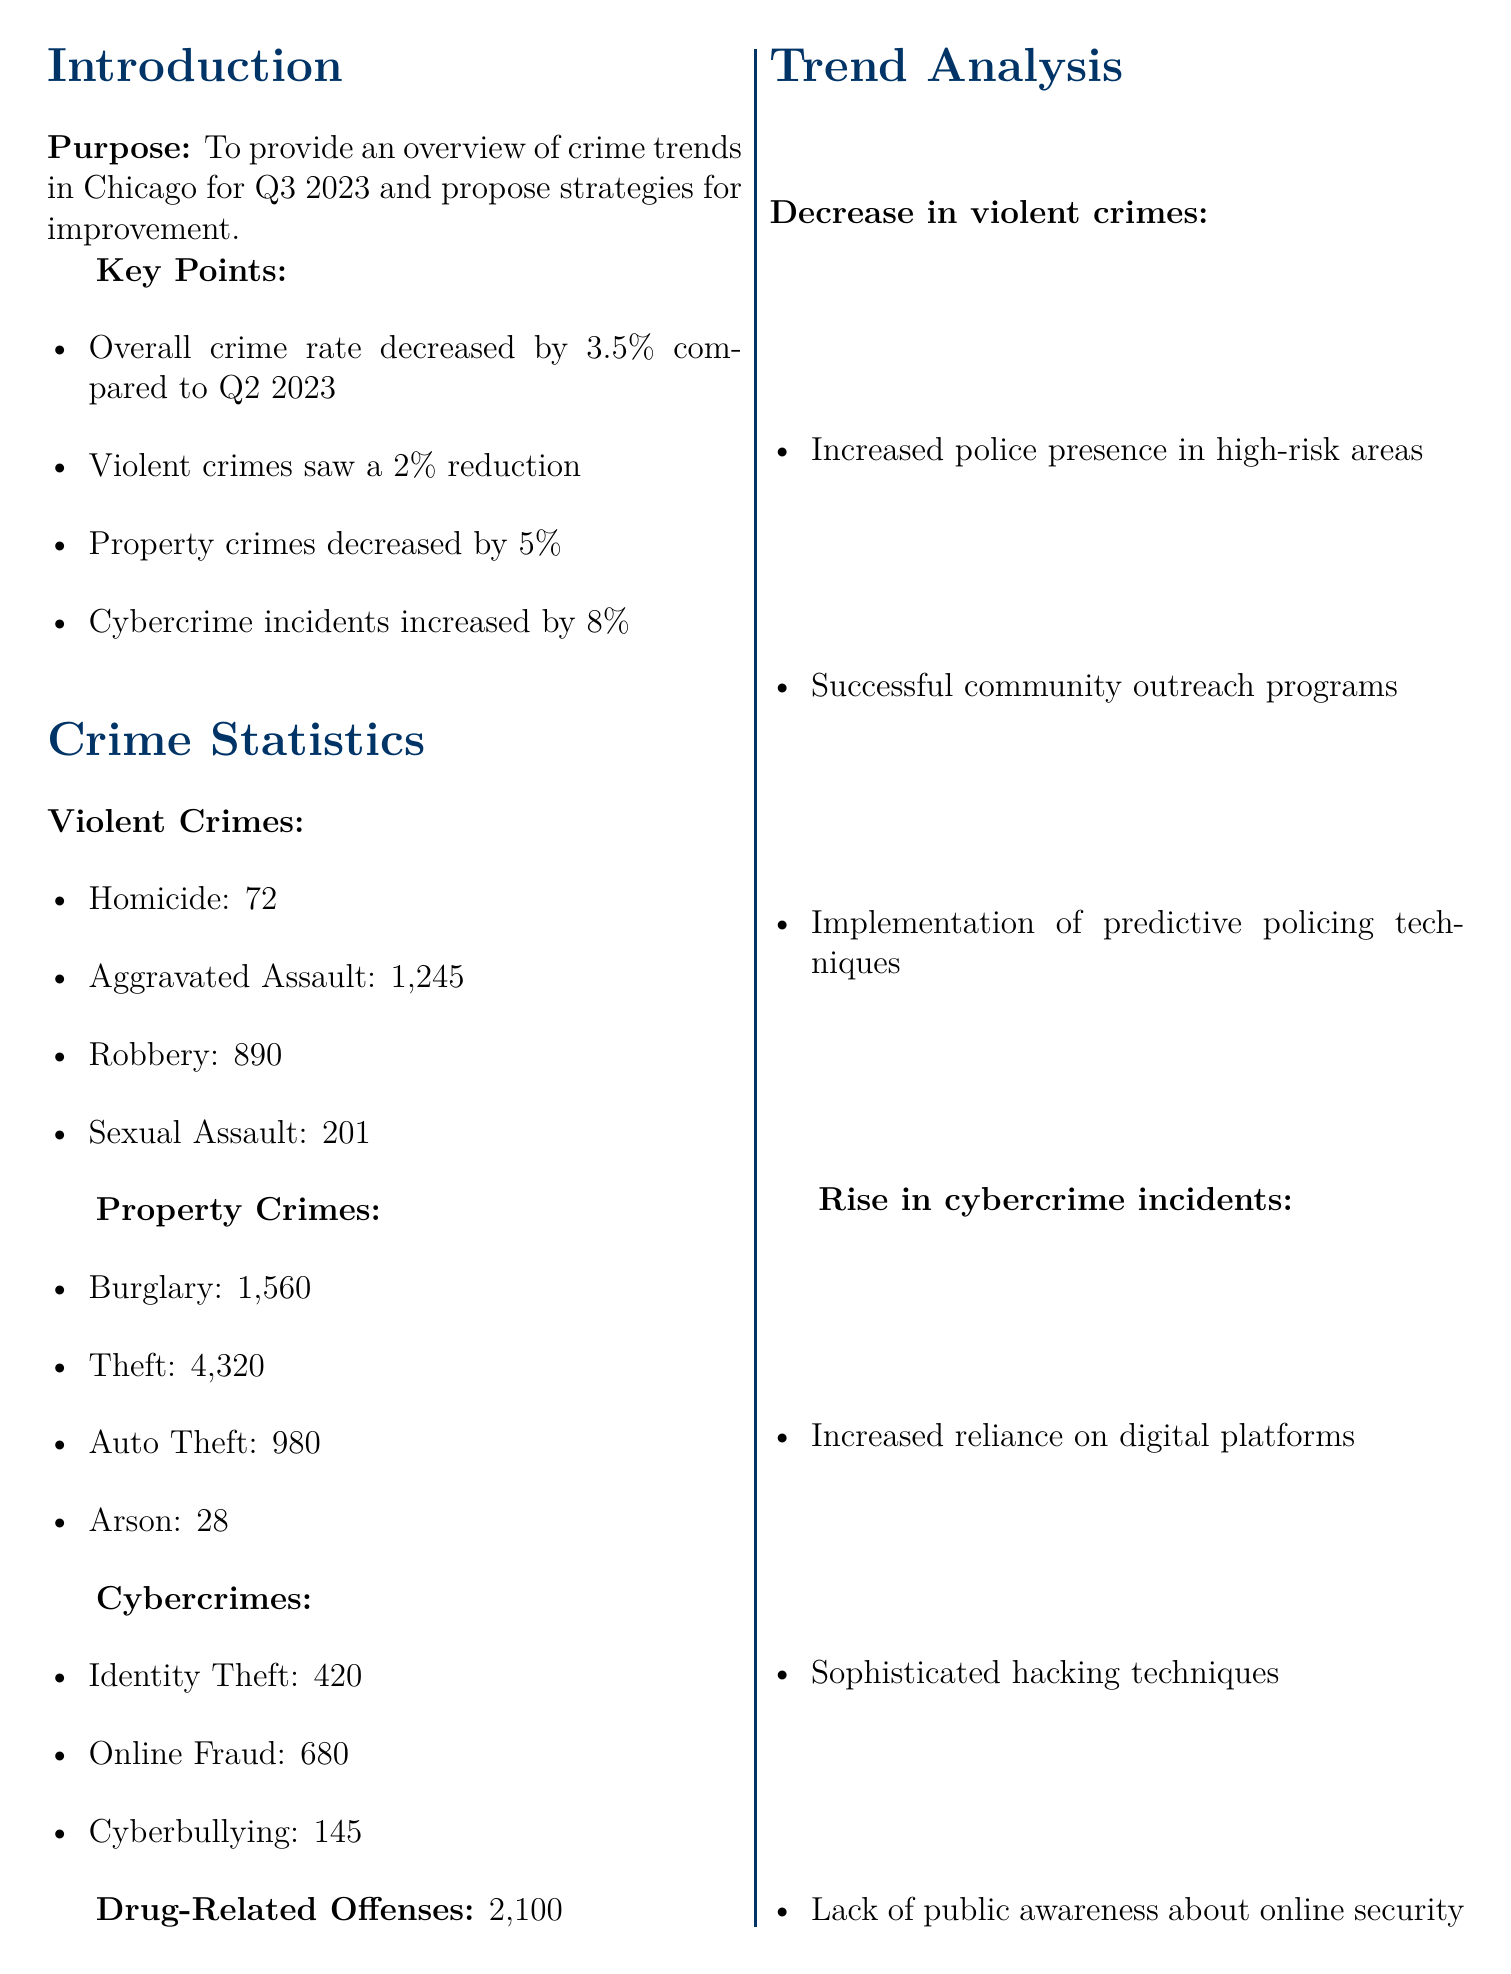What is the overall crime rate change in Q3 2023? The overall crime rate change is stated as a decrease of 3.5% compared to Q2 2023.
Answer: 3.5% How many homicides were reported in Q3 2023? The number of homicides is given in the violent crimes section, which states there were 72 homicides.
Answer: 72 What is the increase percentage of cybercrime incidents? The document states that cybercrime incidents increased by 8%.
Answer: 8% What is one proposed action under the strategy to enhance cybercrime prevention? The document lists several actions, one of which is partnering with the Chicago Tech Association for cybersecurity workshops.
Answer: Partner with Chicago Tech Association for cybersecurity workshops What trend is observed in property crimes? The trend observed is a reduction in property crimes, indicating a positive change in that category.
Answer: Reduction in property crimes What is the total number of drug-related offenses reported? The document specifies that there were 2100 drug-related offenses reported in Q3 2023.
Answer: 2100 Who is the head of the Cybercrime Unit? The memo provides a contact for the Cybercrime Unit, naming Detective Sarah Johnson as the head.
Answer: Detective Sarah Johnson What is the main goal of the proposed strategies? The goal of the proposed strategies is to address the rise in cybercrime while maintaining progress in reducing other crime rates.
Answer: Address rise in cybercrime How often will data analysis meetings be conducted according to the proposed strategies? The document states that bi-weekly data analysis meetings with district commanders will be conducted.
Answer: Bi-weekly 